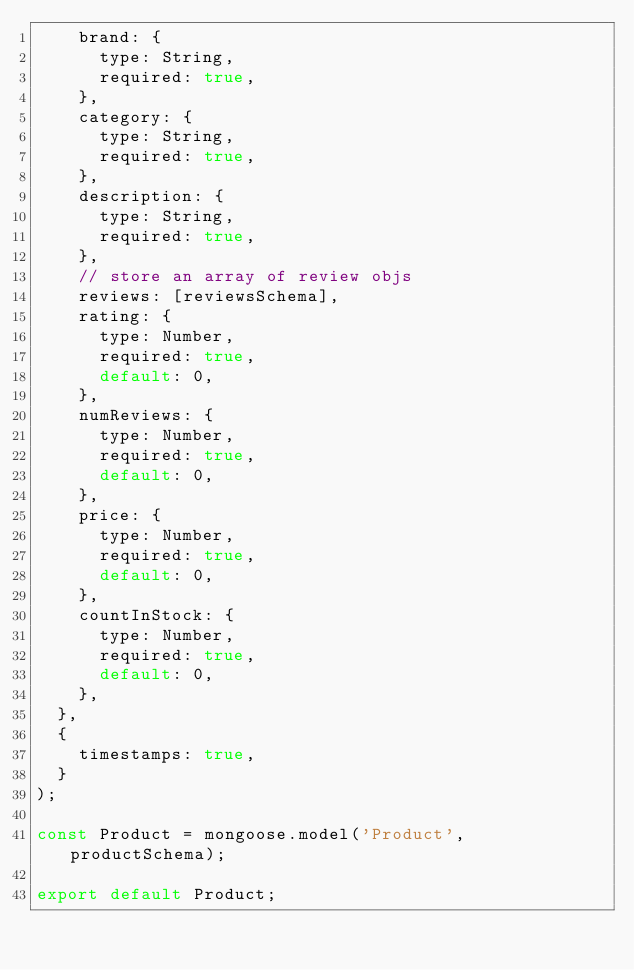Convert code to text. <code><loc_0><loc_0><loc_500><loc_500><_JavaScript_>		brand: {
			type: String,
			required: true,
		},
		category: {
			type: String,
			required: true,
		},
		description: {
			type: String,
			required: true,
		},
		// store an array of review objs
		reviews: [reviewsSchema],
		rating: {
			type: Number,
			required: true,
			default: 0,
		},
		numReviews: {
			type: Number,
			required: true,
			default: 0,
		},
		price: {
			type: Number,
			required: true,
			default: 0,
		},
		countInStock: {
			type: Number,
			required: true,
			default: 0,
		},
	},
	{
		timestamps: true,
	}
);

const Product = mongoose.model('Product', productSchema);

export default Product;
</code> 